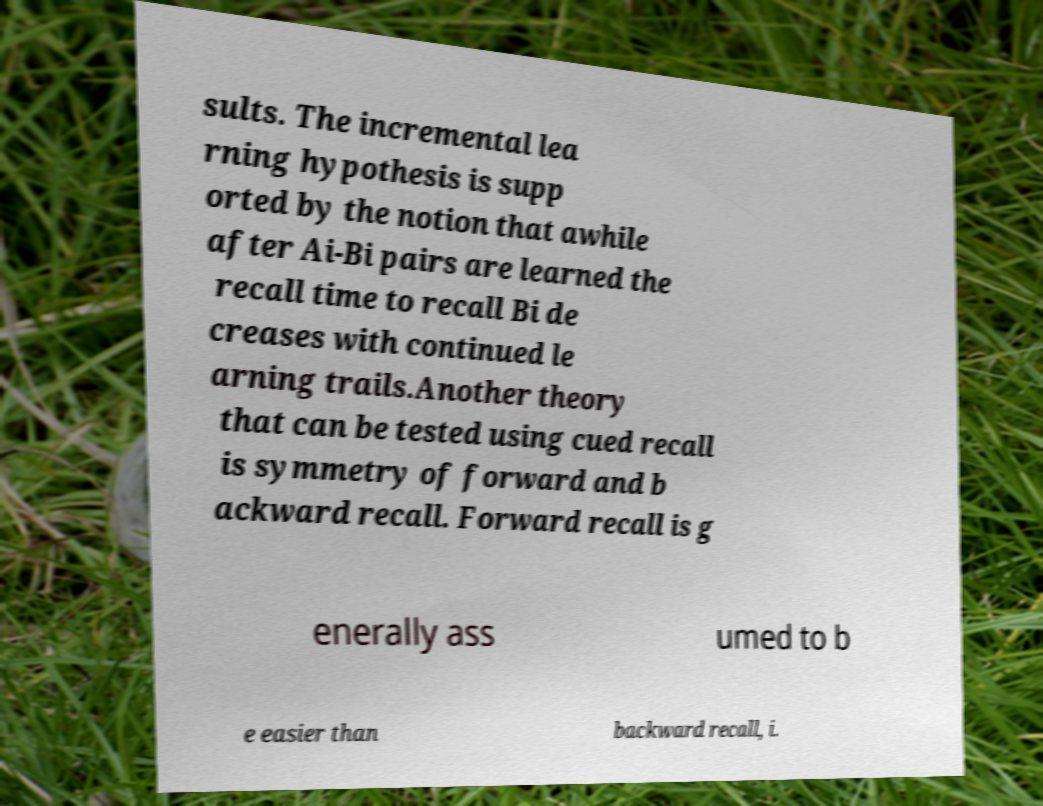Could you assist in decoding the text presented in this image and type it out clearly? sults. The incremental lea rning hypothesis is supp orted by the notion that awhile after Ai-Bi pairs are learned the recall time to recall Bi de creases with continued le arning trails.Another theory that can be tested using cued recall is symmetry of forward and b ackward recall. Forward recall is g enerally ass umed to b e easier than backward recall, i. 